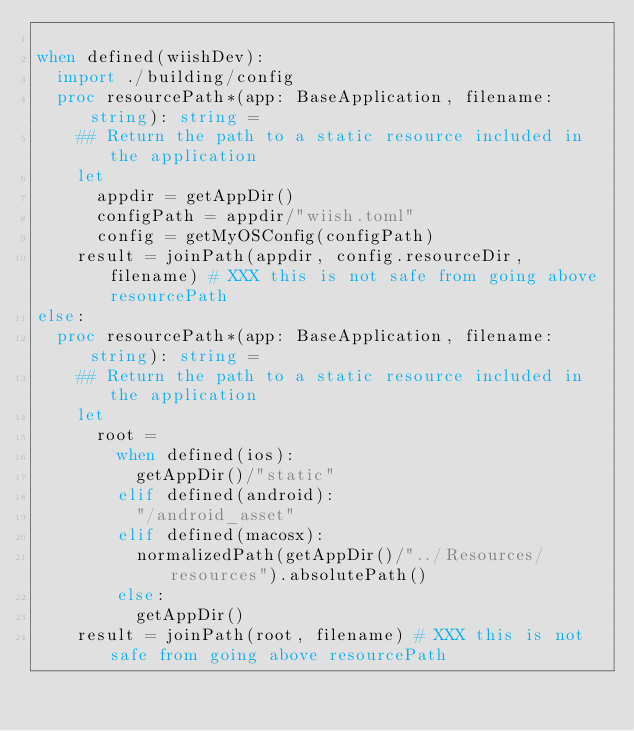<code> <loc_0><loc_0><loc_500><loc_500><_Nim_>
when defined(wiishDev):
  import ./building/config
  proc resourcePath*(app: BaseApplication, filename: string): string =
    ## Return the path to a static resource included in the application
    let
      appdir = getAppDir()
      configPath = appdir/"wiish.toml"
      config = getMyOSConfig(configPath)
    result = joinPath(appdir, config.resourceDir, filename) # XXX this is not safe from going above resourcePath
else:
  proc resourcePath*(app: BaseApplication, filename: string): string =
    ## Return the path to a static resource included in the application
    let
      root = 
        when defined(ios):
          getAppDir()/"static"
        elif defined(android):
          "/android_asset"
        elif defined(macosx):
          normalizedPath(getAppDir()/"../Resources/resources").absolutePath()
        else:
          getAppDir()
    result = joinPath(root, filename) # XXX this is not safe from going above resourcePath
</code> 